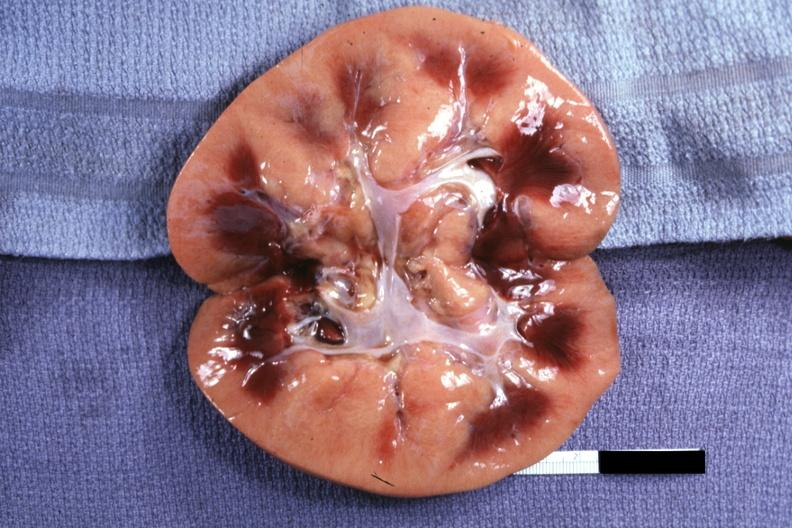s transplant acute rejection present?
Answer the question using a single word or phrase. Yes 